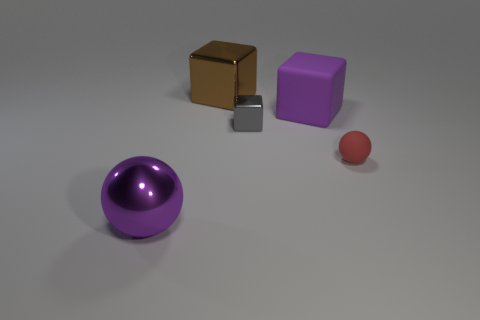How many things are small yellow rubber spheres or rubber blocks?
Provide a succinct answer. 1. There is a big metallic object behind the thing in front of the matte ball; how many cubes are right of it?
Your response must be concise. 2. There is a tiny gray thing that is the same shape as the big rubber object; what is its material?
Keep it short and to the point. Metal. There is a thing that is both to the left of the matte sphere and right of the gray metallic thing; what material is it made of?
Make the answer very short. Rubber. Is the number of brown cubes that are in front of the large brown block less than the number of large cubes behind the large sphere?
Provide a succinct answer. Yes. How many other things are the same size as the shiny sphere?
Your response must be concise. 2. There is a purple object that is left of the large metallic object that is behind the large block in front of the big brown shiny cube; what is its shape?
Make the answer very short. Sphere. How many yellow objects are either tiny rubber spheres or big shiny things?
Offer a very short reply. 0. There is a purple object left of the big brown metallic object; what number of things are in front of it?
Your answer should be compact. 0. Is there anything else that has the same color as the rubber block?
Your answer should be compact. Yes. 